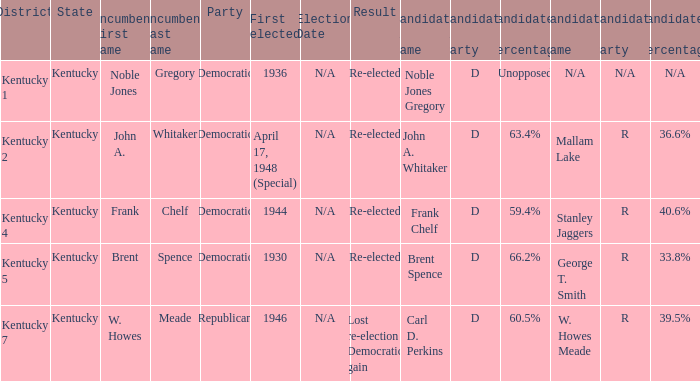List all candidates in the democratic party where the election had the incumbent Frank Chelf running. Frank Chelf (D) 59.4% Stanley Jaggers (R) 40.6%. 